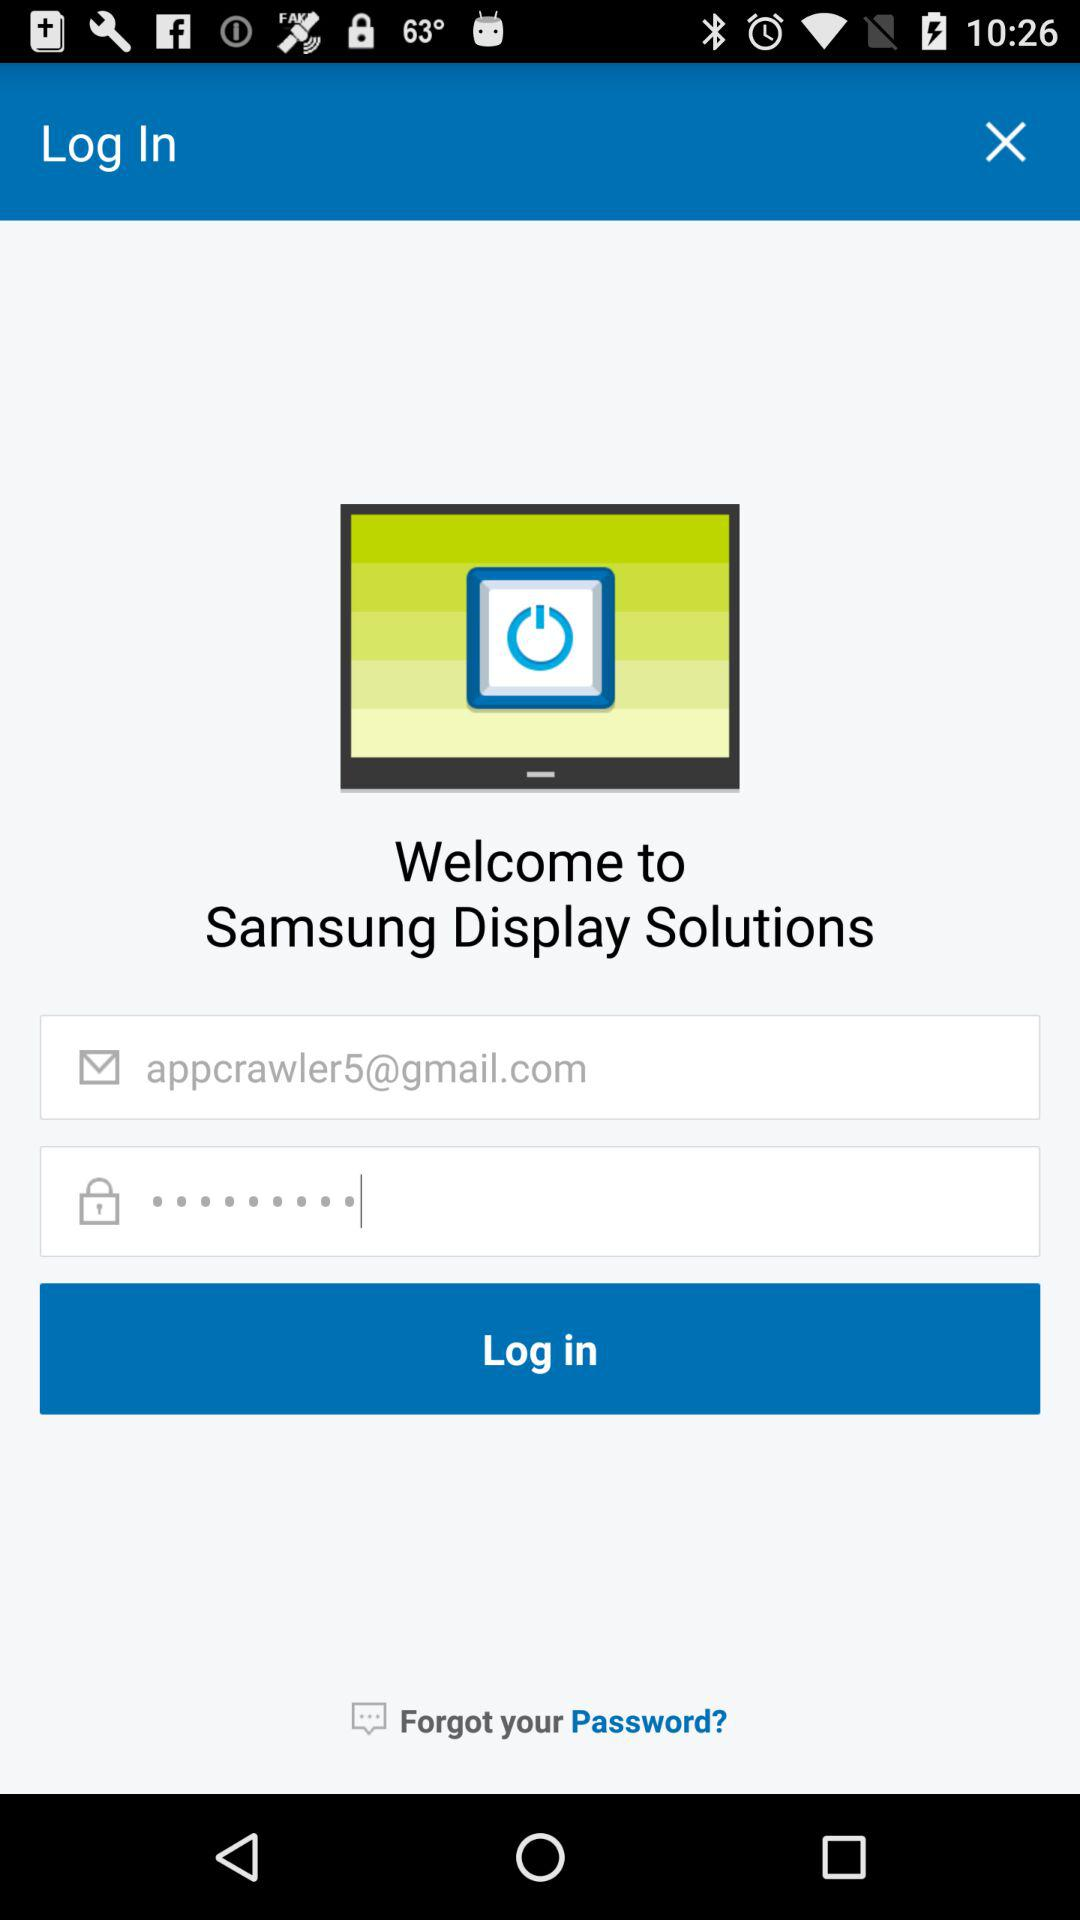What is the given email address? The given email address is appcrawler5@gmail.com. 